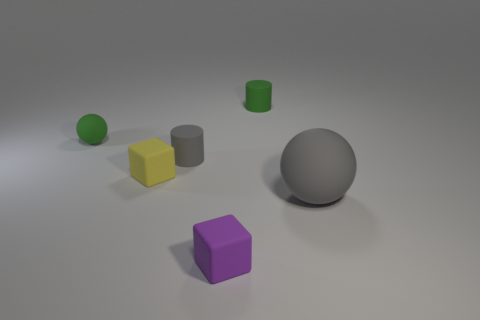There is a big thing; does it have the same color as the matte cylinder in front of the tiny green cylinder?
Keep it short and to the point. Yes. Is there a cylinder of the same color as the large matte sphere?
Provide a short and direct response. Yes. How many big objects are rubber spheres or things?
Your answer should be compact. 1. Are there fewer tiny yellow rubber things than yellow matte cylinders?
Make the answer very short. No. Is the size of the matte cube behind the big matte sphere the same as the gray object to the right of the purple block?
Ensure brevity in your answer.  No. How many purple things are either large cylinders or blocks?
Make the answer very short. 1. Is the number of tiny yellow matte cubes greater than the number of large shiny cylinders?
Ensure brevity in your answer.  Yes. How many objects are small yellow rubber cubes or rubber blocks behind the big gray sphere?
Ensure brevity in your answer.  1. What number of other things are the same shape as the yellow rubber object?
Give a very brief answer. 1. Is the number of big gray balls left of the tiny green rubber cylinder less than the number of yellow matte objects left of the gray sphere?
Your answer should be compact. Yes. 